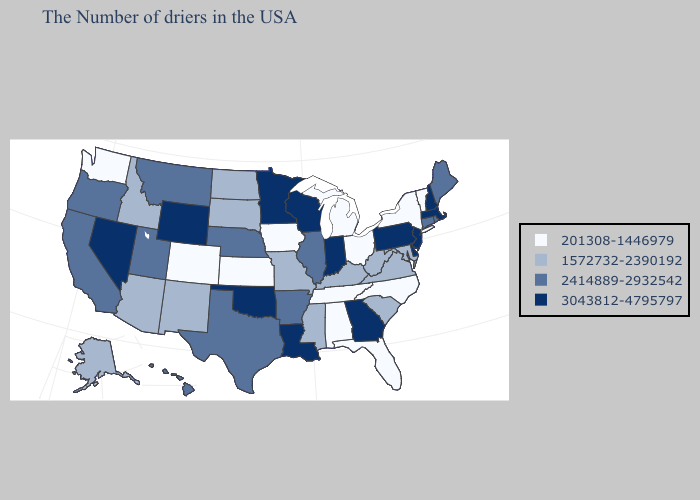Name the states that have a value in the range 201308-1446979?
Short answer required. Vermont, New York, North Carolina, Ohio, Florida, Michigan, Alabama, Tennessee, Iowa, Kansas, Colorado, Washington. What is the highest value in states that border Wisconsin?
Short answer required. 3043812-4795797. Which states have the lowest value in the USA?
Concise answer only. Vermont, New York, North Carolina, Ohio, Florida, Michigan, Alabama, Tennessee, Iowa, Kansas, Colorado, Washington. Does North Carolina have the lowest value in the South?
Write a very short answer. Yes. Among the states that border Iowa , which have the highest value?
Quick response, please. Wisconsin, Minnesota. Among the states that border Utah , which have the lowest value?
Short answer required. Colorado. What is the value of Mississippi?
Concise answer only. 1572732-2390192. What is the value of Oregon?
Short answer required. 2414889-2932542. Does Colorado have a higher value than Florida?
Give a very brief answer. No. Name the states that have a value in the range 1572732-2390192?
Short answer required. Maryland, Virginia, South Carolina, West Virginia, Kentucky, Mississippi, Missouri, South Dakota, North Dakota, New Mexico, Arizona, Idaho, Alaska. What is the value of Connecticut?
Concise answer only. 2414889-2932542. What is the lowest value in the USA?
Write a very short answer. 201308-1446979. Which states have the highest value in the USA?
Write a very short answer. Massachusetts, New Hampshire, New Jersey, Delaware, Pennsylvania, Georgia, Indiana, Wisconsin, Louisiana, Minnesota, Oklahoma, Wyoming, Nevada. Among the states that border Virginia , does Kentucky have the highest value?
Short answer required. Yes. Among the states that border Michigan , which have the lowest value?
Concise answer only. Ohio. 